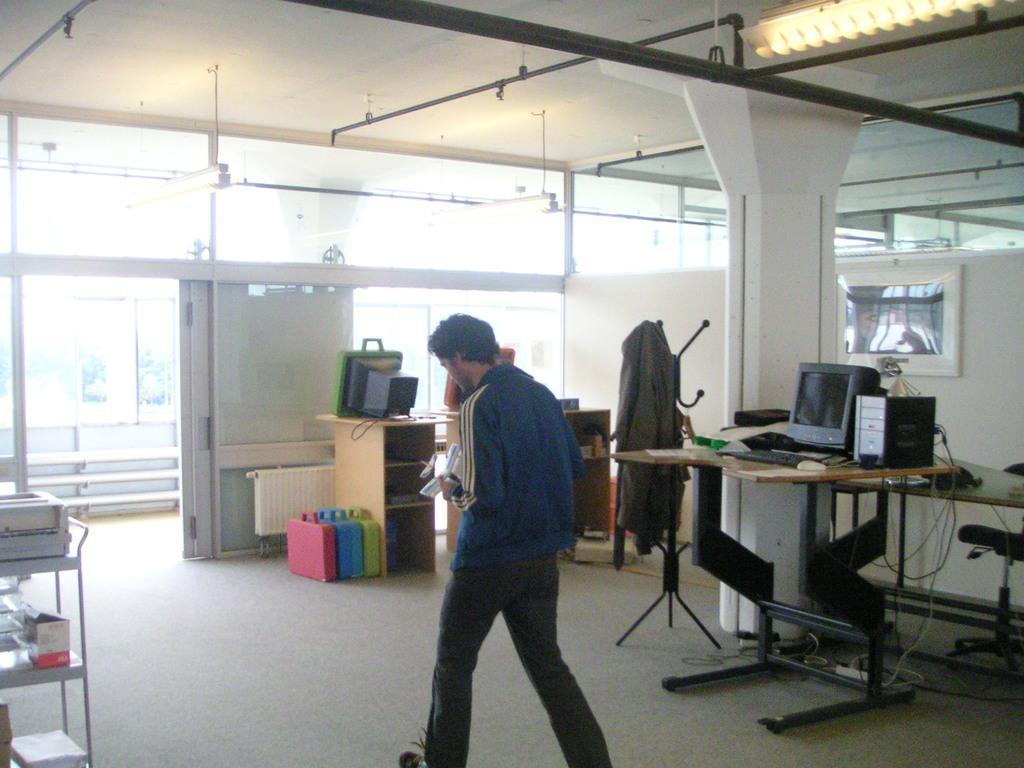Can you describe this image briefly? This picture shows a man walking holding papers in his hands and we see few computers on the table and we see a coat Hanging to the stand and a photo frame to the wall and we see lights to the ceiling and few boxes on the floor and a metal rack on the side. 